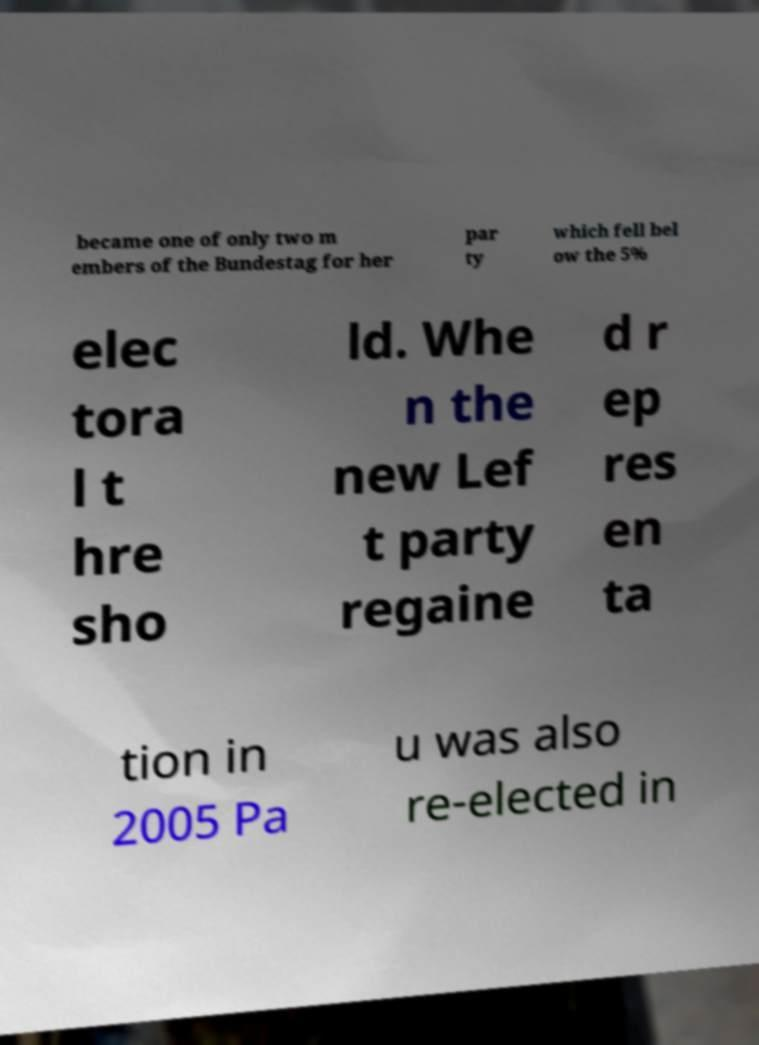I need the written content from this picture converted into text. Can you do that? became one of only two m embers of the Bundestag for her par ty which fell bel ow the 5% elec tora l t hre sho ld. Whe n the new Lef t party regaine d r ep res en ta tion in 2005 Pa u was also re-elected in 